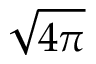<formula> <loc_0><loc_0><loc_500><loc_500>\sqrt { 4 \pi }</formula> 